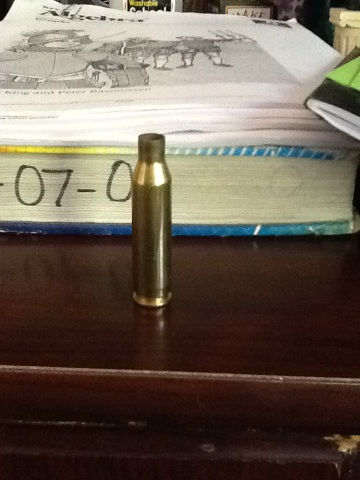Can you explain the purpose of this object shown? This is a brass bullet casing. It's primarily used to contain the gunpowder, primer, and the bullet itself, which together enable the functioning of a firearm. After the gun is fired, the casing is ejected as the bullet is propelled forward. 